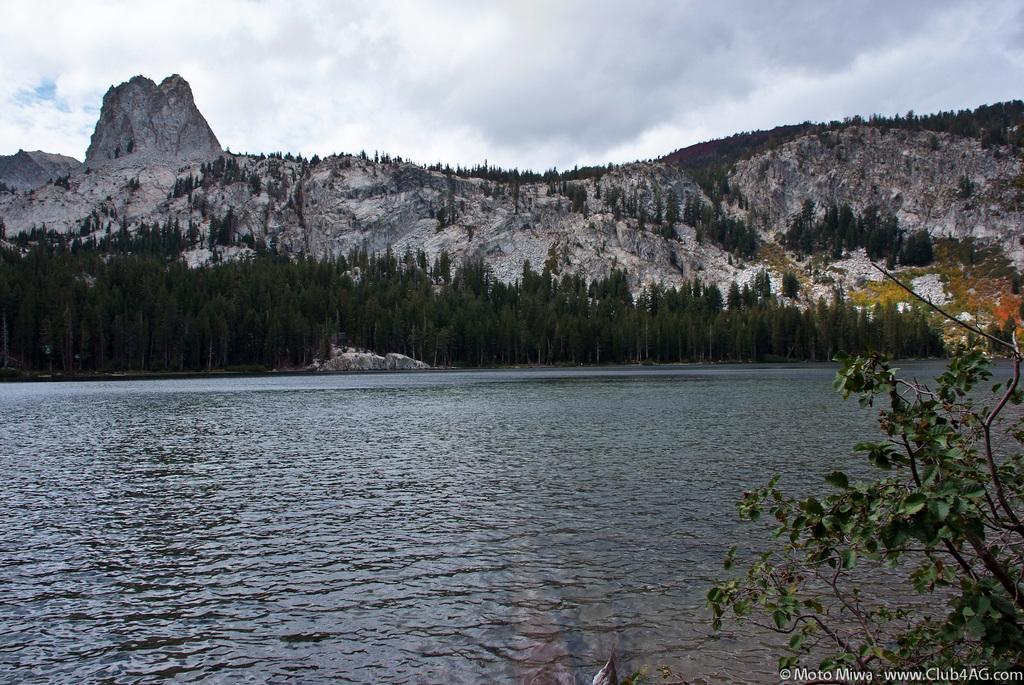How would you summarize this image in a sentence or two? In this image we can see water, plant, trees, hills and the sky with clouds in the background. Here we can see the watermark. 